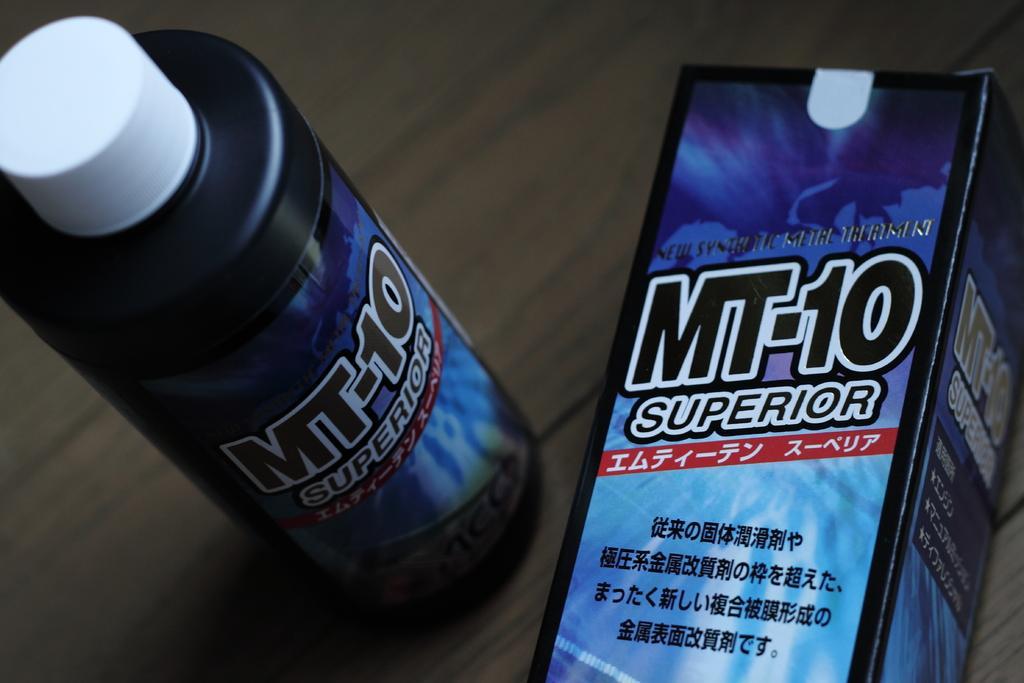Describe this image in one or two sentences. there is a black bottle and a box on which superior-10 is written. 